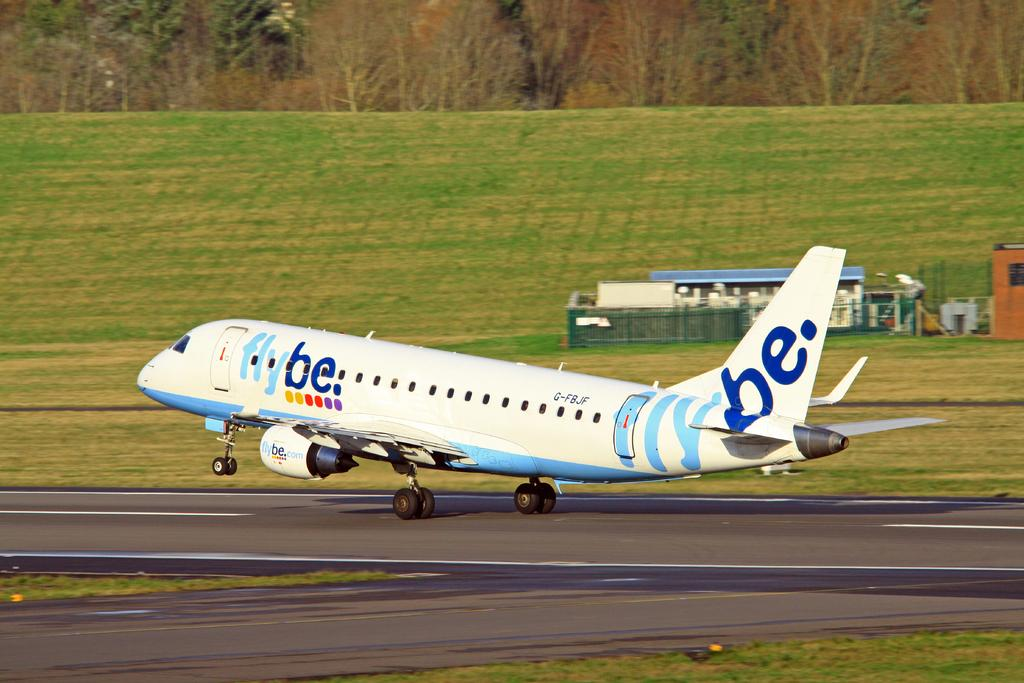<image>
Render a clear and concise summary of the photo. a FLY BE plane taking off from a runway 